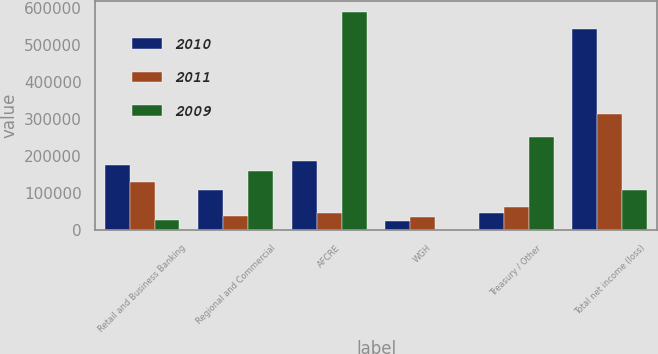Convert chart to OTSL. <chart><loc_0><loc_0><loc_500><loc_500><stacked_bar_chart><ecel><fcel>Retail and Business Banking<fcel>Regional and Commercial<fcel>AFCRE<fcel>WGH<fcel>Treasury / Other<fcel>Total net income (loss)<nl><fcel>2010<fcel>175395<fcel>109846<fcel>186151<fcel>25883<fcel>45338<fcel>542613<nl><fcel>2011<fcel>131036<fcel>38462<fcel>46492<fcel>34801<fcel>61556<fcel>312347<nl><fcel>2009<fcel>26479<fcel>158736<fcel>588154<fcel>1743<fcel>251265<fcel>109846<nl></chart> 